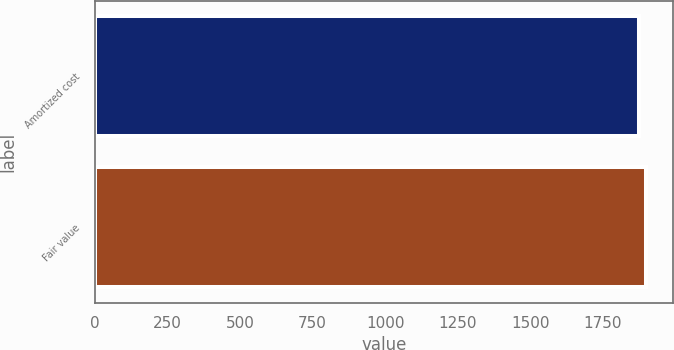Convert chart. <chart><loc_0><loc_0><loc_500><loc_500><bar_chart><fcel>Amortized cost<fcel>Fair value<nl><fcel>1874<fcel>1897<nl></chart> 